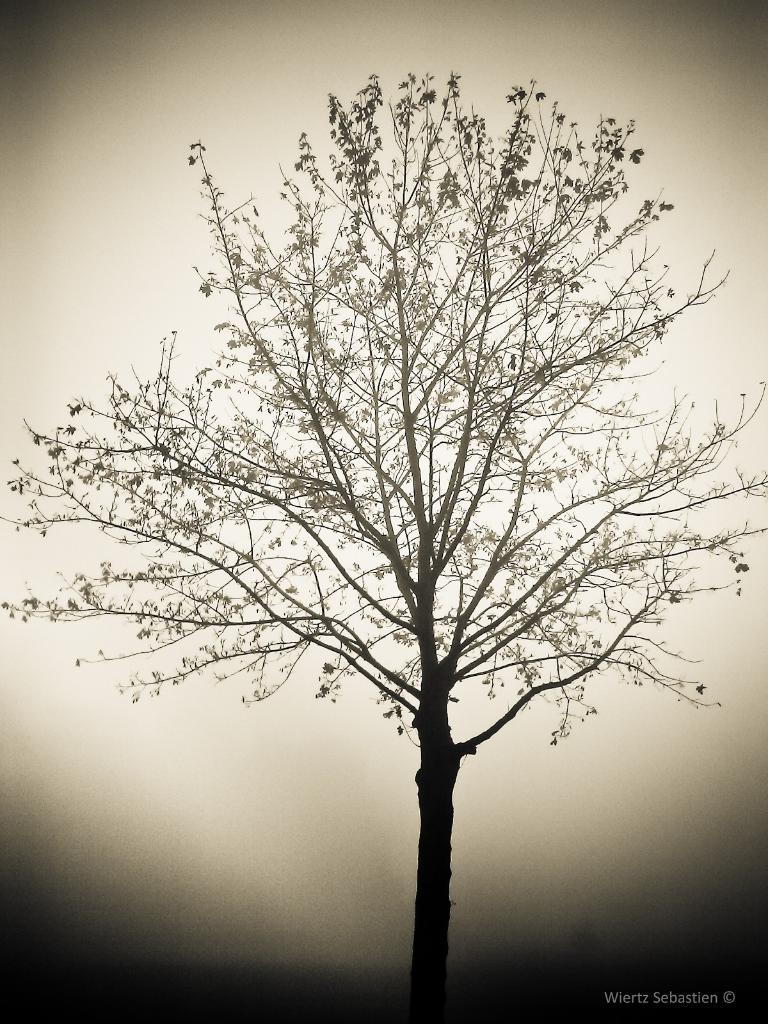What type of plant is present in the image? The image contains a tree with branches and leaves. Can you describe any additional features of the tree? The tree has branches and leaves, but no other specific features are mentioned. Is there any text or logo visible in the image? Yes, there is a watermark in the bottom right corner of the image. What type of sack can be seen hanging from the tree in the image? There is no sack present in the image; it only contains a tree with branches and leaves. What type of linen is draped over the branches of the tree in the image? There is no linen present in the image; it only contains a tree with branches and leaves. 